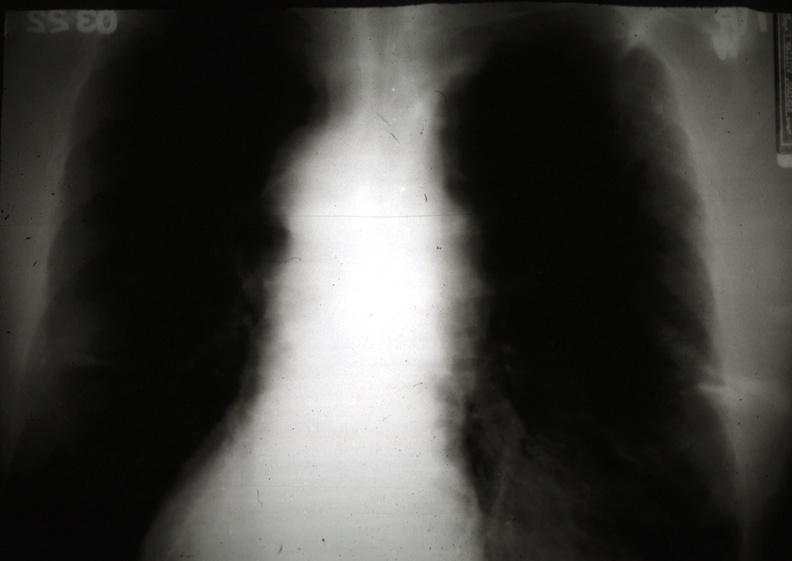s thymus present?
Answer the question using a single word or phrase. Yes 